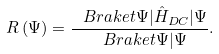<formula> <loc_0><loc_0><loc_500><loc_500>R \left ( \Psi \right ) = \frac { \ B r a k e t { \Psi | \hat { H } _ { D C } | \Psi } } { \ B r a k e t { \Psi | \Psi } } .</formula> 